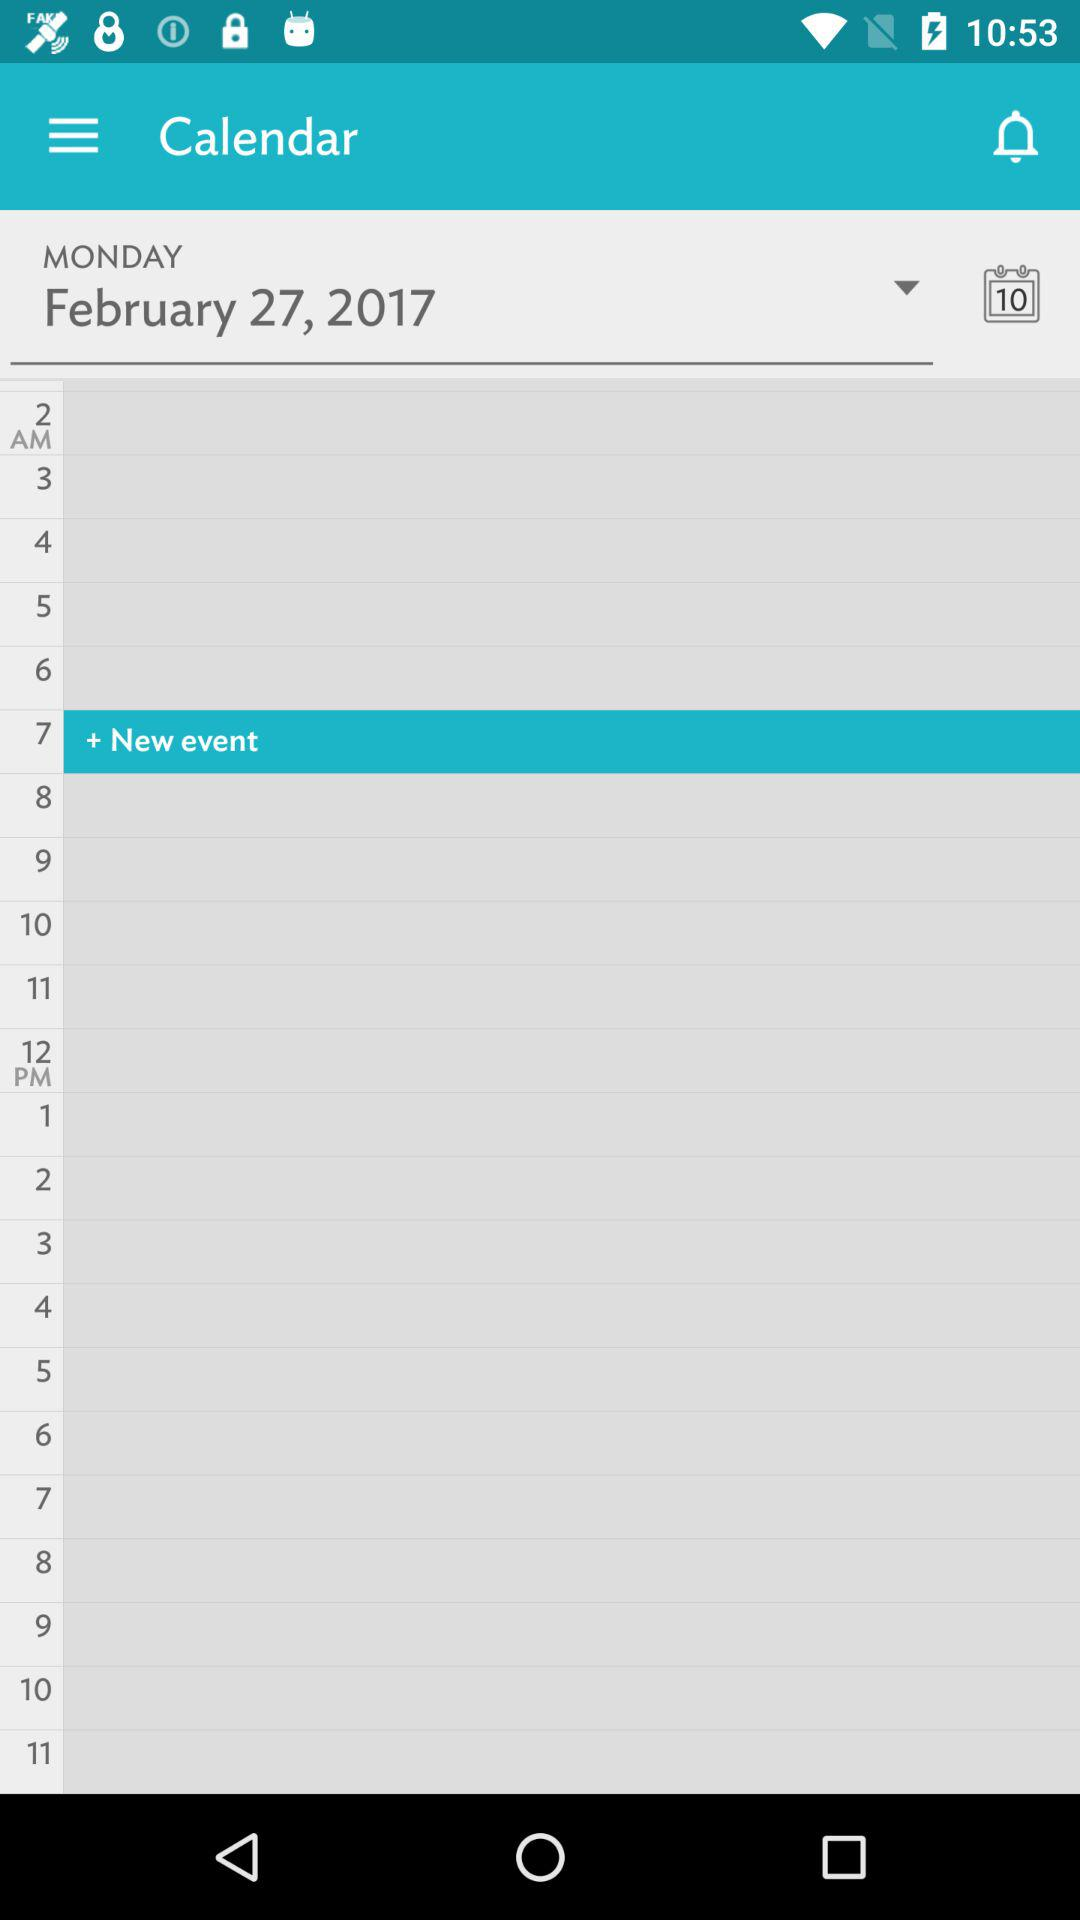How long does the event last?
When the provided information is insufficient, respond with <no answer>. <no answer> 